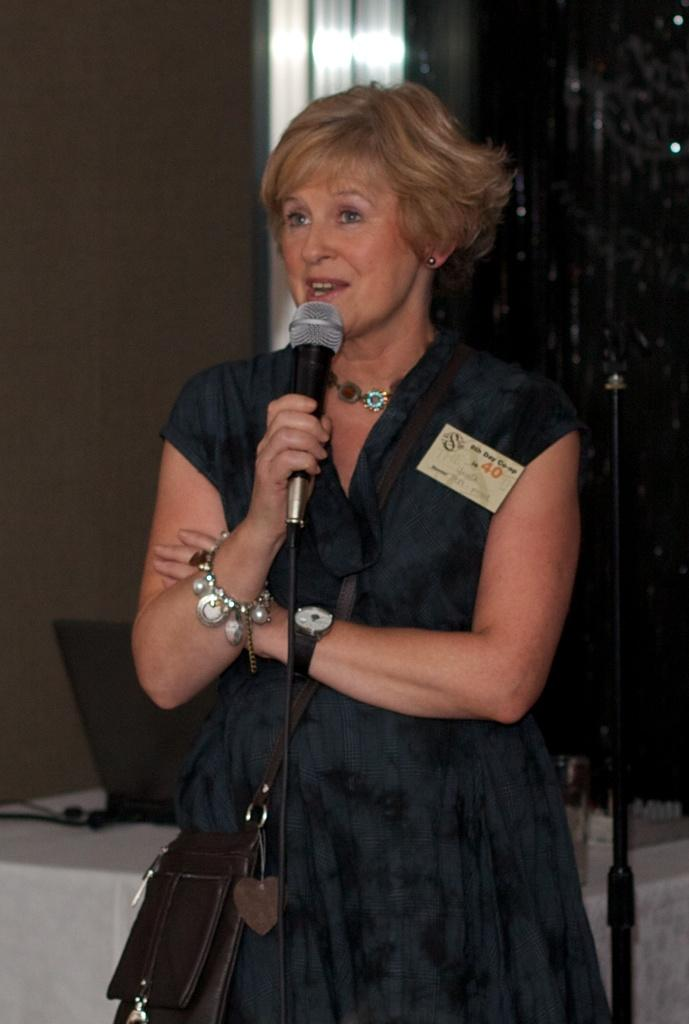What is the woman in the image doing? The woman is standing in the image and holding a mic in her hand. What object is present in the image that is commonly used for communication or presentations? There is a laptop in the image. What can be seen on the table in the image? There is a glass on a table in the image. How would you describe the background of the image? The background of the image is blurred. How many snails can be seen crawling on the laptop in the image? There are no snails present in the image, and therefore none can be seen crawling on the laptop. What type of chess pieces are visible on the table in the image? There are no chess pieces visible on the table in the image. 